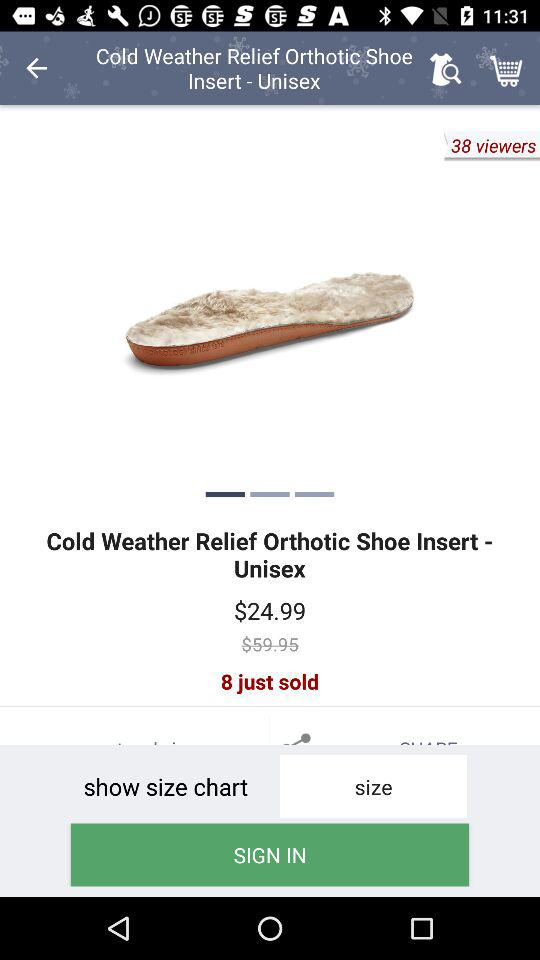How many sizes of the shoe insert are available?
When the provided information is insufficient, respond with <no answer>. <no answer> 